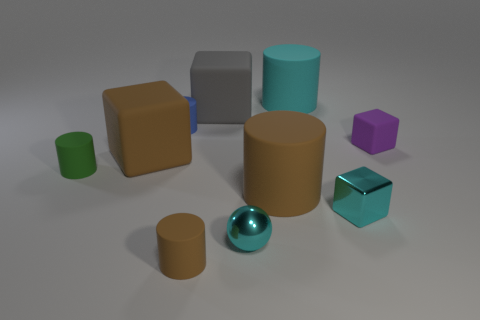What is the material of the tiny thing that is both to the right of the large gray rubber object and to the left of the large cyan cylinder? metal 